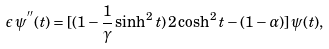<formula> <loc_0><loc_0><loc_500><loc_500>\epsilon \, \psi ^ { ^ { \prime \prime } } ( t ) = [ ( 1 - \frac { 1 } { \gamma } \sinh ^ { 2 } t ) \, 2 \cosh ^ { 2 } t - ( 1 - \alpha ) ] \, \psi ( t ) ,</formula> 